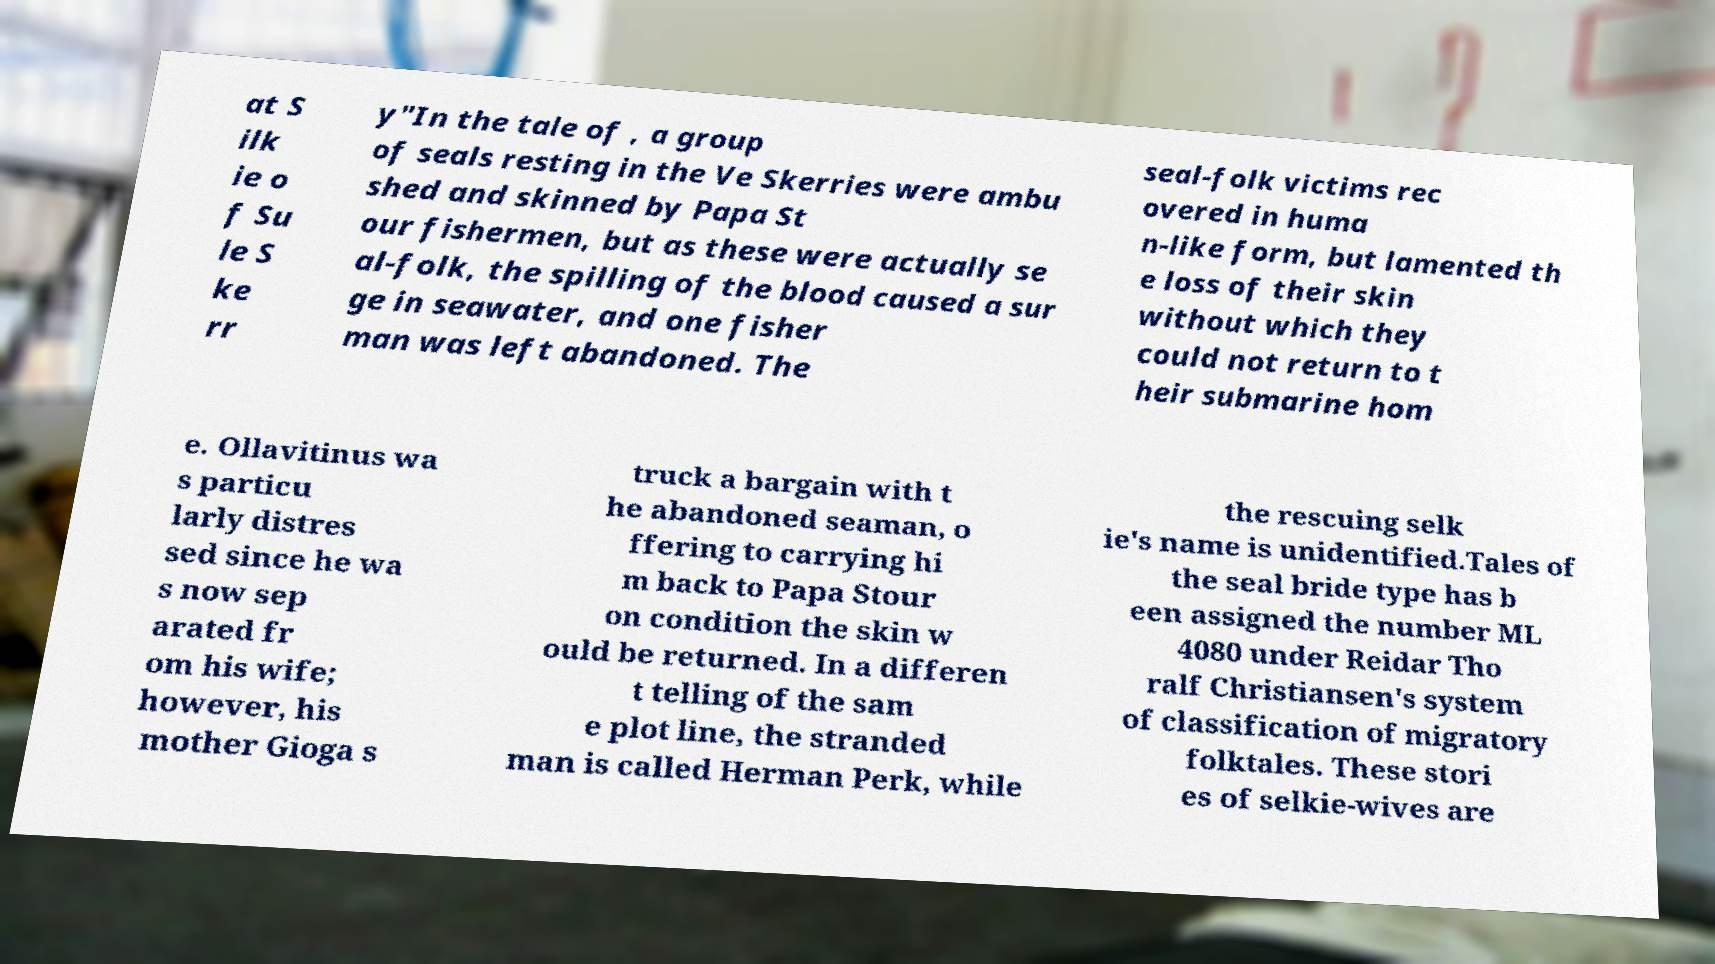Could you extract and type out the text from this image? at S ilk ie o f Su le S ke rr y"In the tale of , a group of seals resting in the Ve Skerries were ambu shed and skinned by Papa St our fishermen, but as these were actually se al-folk, the spilling of the blood caused a sur ge in seawater, and one fisher man was left abandoned. The seal-folk victims rec overed in huma n-like form, but lamented th e loss of their skin without which they could not return to t heir submarine hom e. Ollavitinus wa s particu larly distres sed since he wa s now sep arated fr om his wife; however, his mother Gioga s truck a bargain with t he abandoned seaman, o ffering to carrying hi m back to Papa Stour on condition the skin w ould be returned. In a differen t telling of the sam e plot line, the stranded man is called Herman Perk, while the rescuing selk ie's name is unidentified.Tales of the seal bride type has b een assigned the number ML 4080 under Reidar Tho ralf Christiansen's system of classification of migratory folktales. These stori es of selkie-wives are 